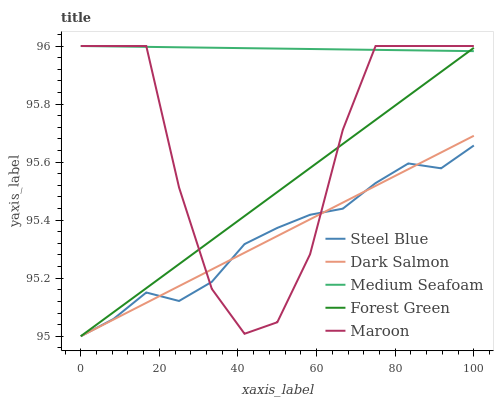Does Steel Blue have the minimum area under the curve?
Answer yes or no. Yes. Does Medium Seafoam have the maximum area under the curve?
Answer yes or no. Yes. Does Medium Seafoam have the minimum area under the curve?
Answer yes or no. No. Does Steel Blue have the maximum area under the curve?
Answer yes or no. No. Is Dark Salmon the smoothest?
Answer yes or no. Yes. Is Maroon the roughest?
Answer yes or no. Yes. Is Medium Seafoam the smoothest?
Answer yes or no. No. Is Medium Seafoam the roughest?
Answer yes or no. No. Does Forest Green have the lowest value?
Answer yes or no. Yes. Does Medium Seafoam have the lowest value?
Answer yes or no. No. Does Maroon have the highest value?
Answer yes or no. Yes. Does Steel Blue have the highest value?
Answer yes or no. No. Is Dark Salmon less than Medium Seafoam?
Answer yes or no. Yes. Is Medium Seafoam greater than Steel Blue?
Answer yes or no. Yes. Does Medium Seafoam intersect Forest Green?
Answer yes or no. Yes. Is Medium Seafoam less than Forest Green?
Answer yes or no. No. Is Medium Seafoam greater than Forest Green?
Answer yes or no. No. Does Dark Salmon intersect Medium Seafoam?
Answer yes or no. No. 